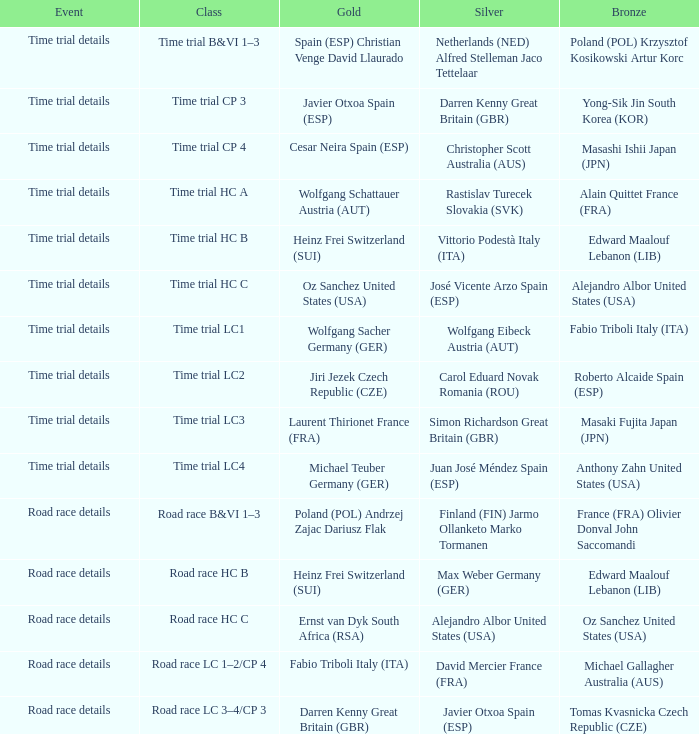What is the event when the class is time trial hc a? Time trial details. 